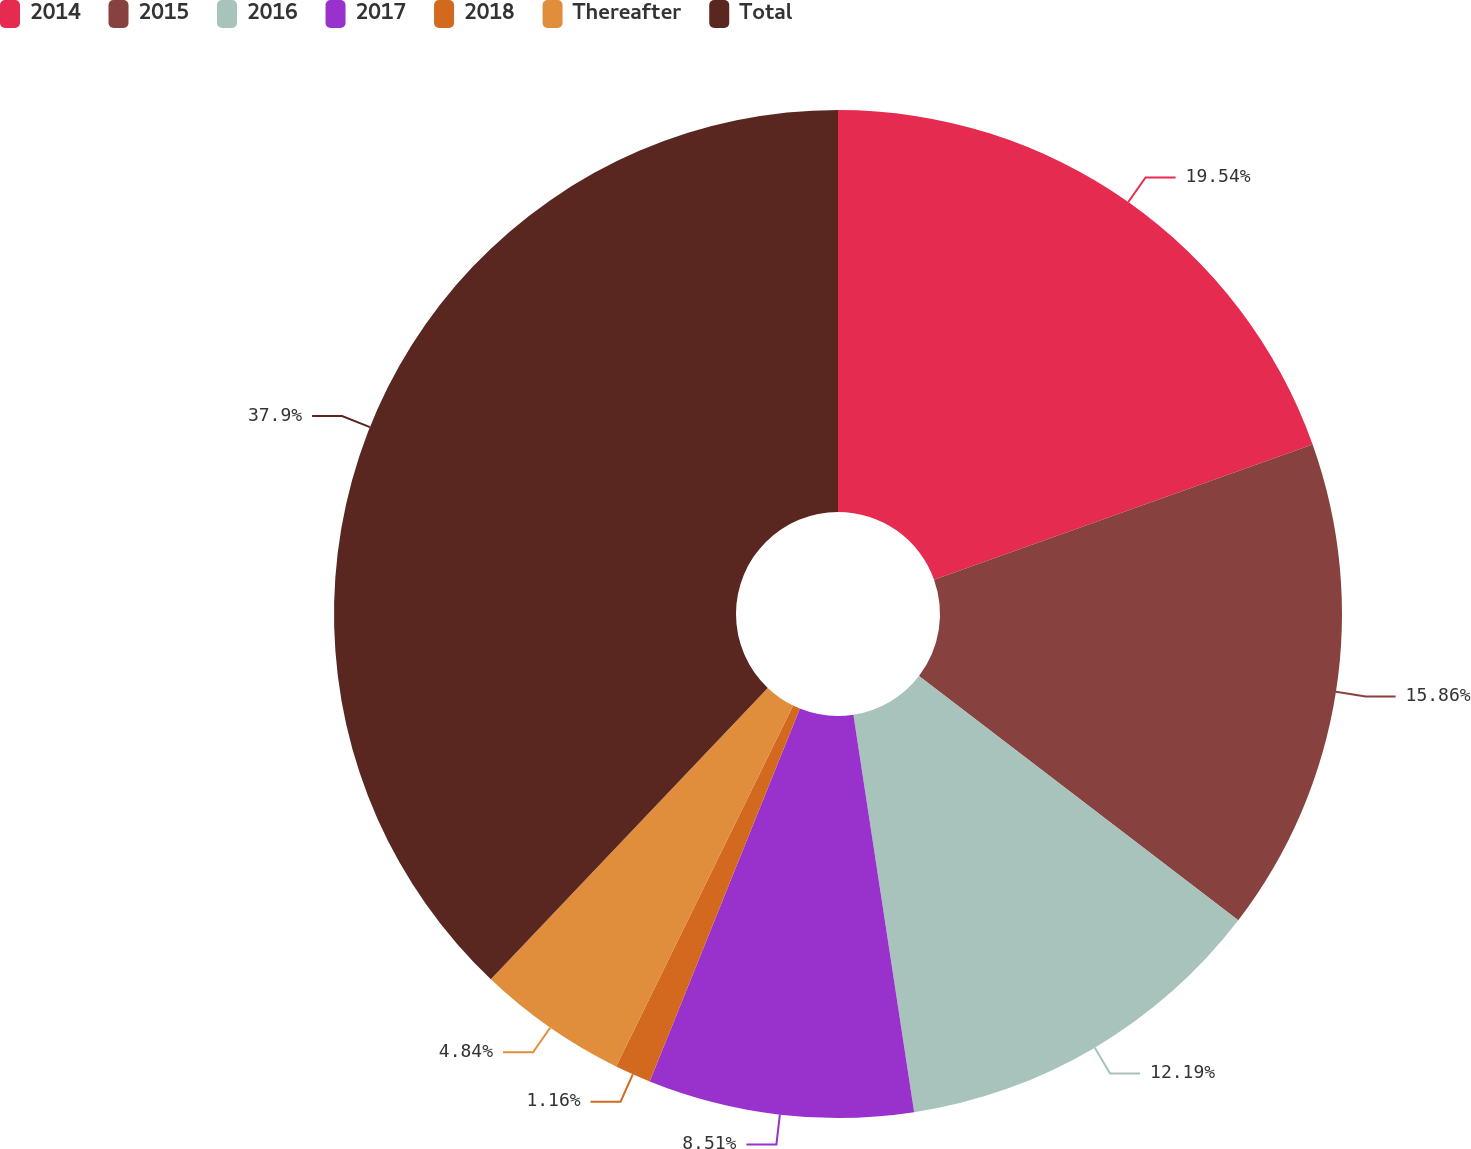<chart> <loc_0><loc_0><loc_500><loc_500><pie_chart><fcel>2014<fcel>2015<fcel>2016<fcel>2017<fcel>2018<fcel>Thereafter<fcel>Total<nl><fcel>19.54%<fcel>15.86%<fcel>12.19%<fcel>8.51%<fcel>1.16%<fcel>4.84%<fcel>37.91%<nl></chart> 